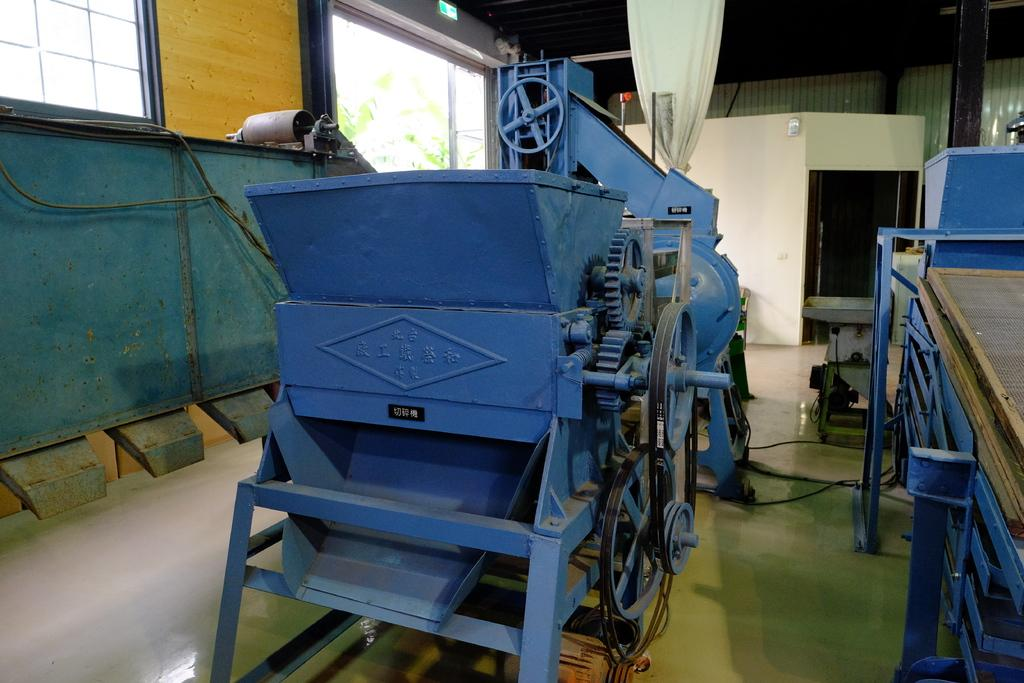What is the main object in the image? There is a machine in the image. Where is the machine located? The machine is on the floor. What color is the machine? The machine is blue in color. What else can be seen on the floor near the machine? There are objects placed on the floor near the machine. What joke is the stranger telling near the blue machine in the image? There is no stranger or joke present in the image; it only features a blue machine and objects on the floor. 